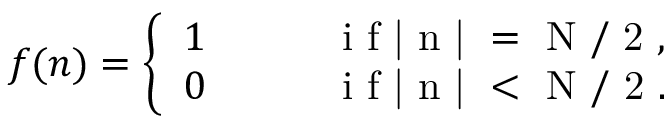Convert formula to latex. <formula><loc_0><loc_0><loc_500><loc_500>f ( n ) = \left \{ \begin{array} { l l } { 1 } & { \quad i f | n | = N / 2 , } \\ { 0 } & { \quad i f | n | < N / 2 . } \end{array}</formula> 